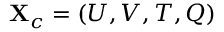Convert formula to latex. <formula><loc_0><loc_0><loc_500><loc_500>X _ { c } = \left ( U , V , T , Q \right )</formula> 